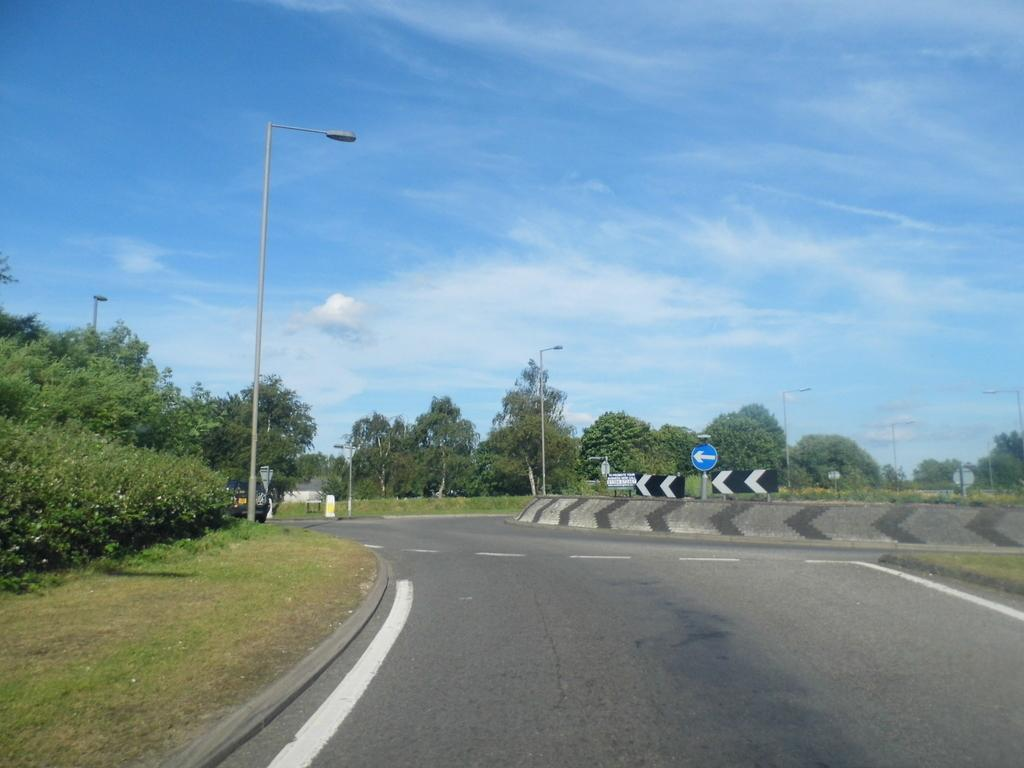What type of structures can be seen in the image? There are street lights in the image. What type of vegetation is present in the image? There are trees in the image. What is the nature of the pathway in the image? There is a road with white lines in the image. What type of ground cover is visible in the image? There is grass in the image. What type of informational or directional signs are present in the image? There are sign boards in the image. What can be seen in the background of the image? The sky is visible in the background of the image. What type of ornament is hanging from the chin of the person in the image? There is no person present in the image, and therefore no ornament hanging from a chin. What is the scale of the street lights in the image? The scale of the street lights cannot be determined from the image alone, as there is no reference point provided. 